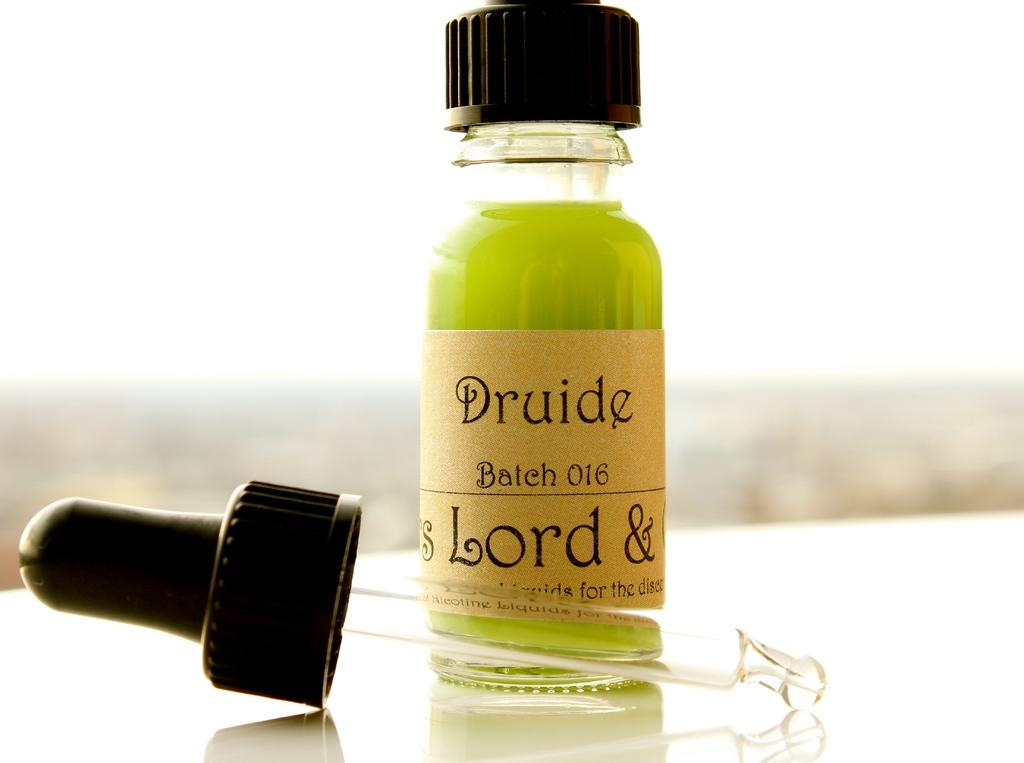<image>
Summarize the visual content of the image. A bottle of green druide fluid with its dropper in front of it. 